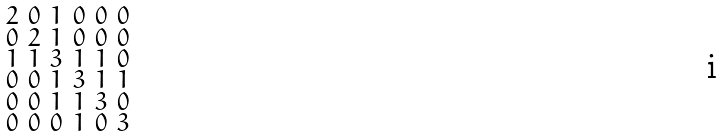<formula> <loc_0><loc_0><loc_500><loc_500>\begin{smallmatrix} 2 & 0 & 1 & 0 & 0 & 0 \\ 0 & 2 & 1 & 0 & 0 & 0 \\ 1 & 1 & 3 & 1 & 1 & 0 \\ 0 & 0 & 1 & 3 & 1 & 1 \\ 0 & 0 & 1 & 1 & 3 & 0 \\ 0 & 0 & 0 & 1 & 0 & 3 \end{smallmatrix}</formula> 